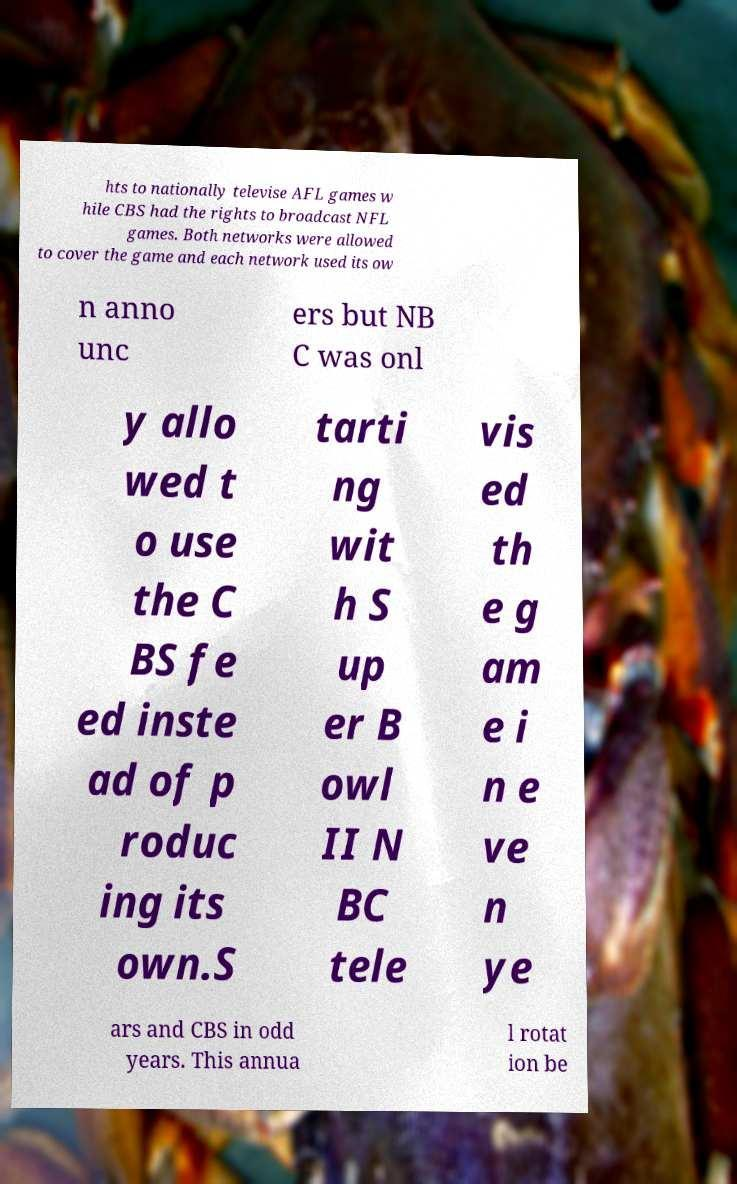Can you read and provide the text displayed in the image?This photo seems to have some interesting text. Can you extract and type it out for me? hts to nationally televise AFL games w hile CBS had the rights to broadcast NFL games. Both networks were allowed to cover the game and each network used its ow n anno unc ers but NB C was onl y allo wed t o use the C BS fe ed inste ad of p roduc ing its own.S tarti ng wit h S up er B owl II N BC tele vis ed th e g am e i n e ve n ye ars and CBS in odd years. This annua l rotat ion be 